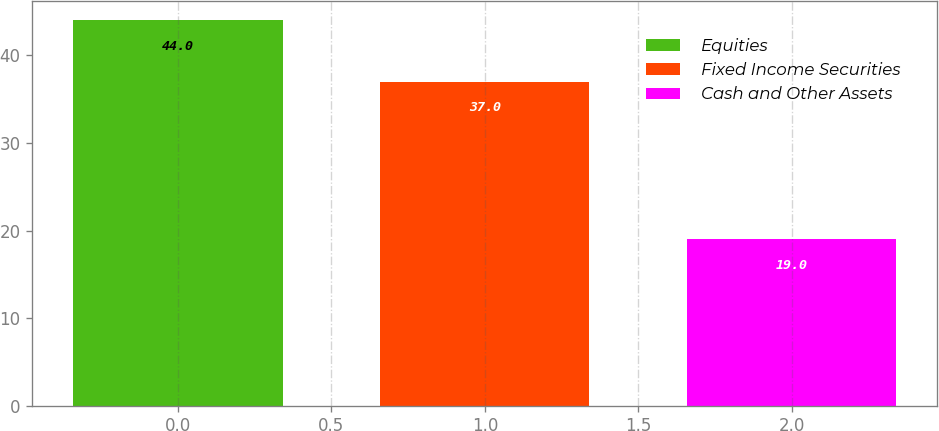Convert chart to OTSL. <chart><loc_0><loc_0><loc_500><loc_500><bar_chart><fcel>Equities<fcel>Fixed Income Securities<fcel>Cash and Other Assets<nl><fcel>44<fcel>37<fcel>19<nl></chart> 